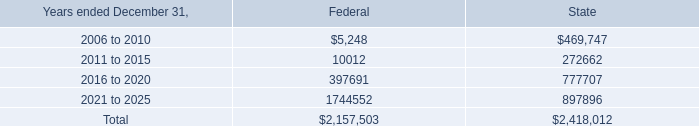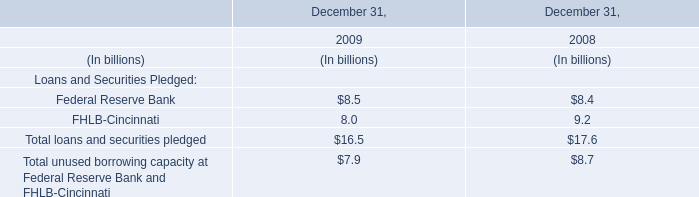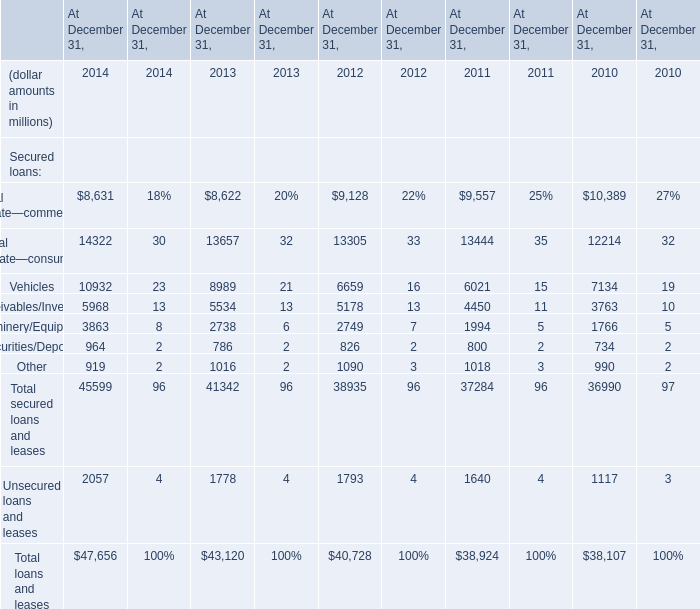what was the percentage of the anticipated approximate tax refund in 2003 based on the nol $ 90.0 million . 
Computations: (90.0 / 380.0)
Answer: 0.23684. What's the sum of Machinery/Equipment of At December 31, 2013, 2006 to 2010 of State, and Vehicles of At December 31, 2014 ? 
Computations: ((2738.0 + 469747.0) + 10932.0)
Answer: 483417.0. 